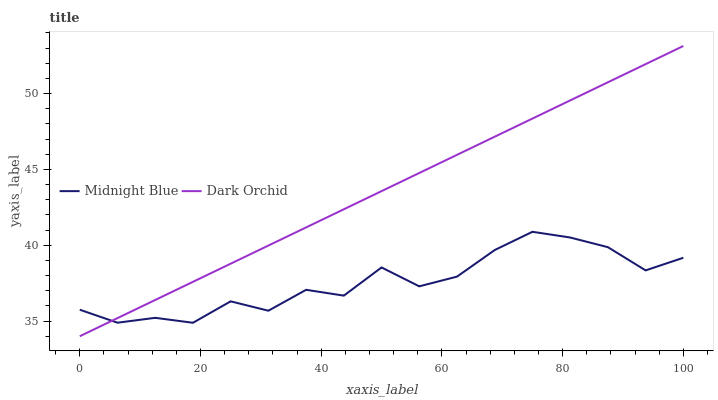Does Midnight Blue have the minimum area under the curve?
Answer yes or no. Yes. Does Dark Orchid have the maximum area under the curve?
Answer yes or no. Yes. Does Dark Orchid have the minimum area under the curve?
Answer yes or no. No. Is Dark Orchid the smoothest?
Answer yes or no. Yes. Is Midnight Blue the roughest?
Answer yes or no. Yes. Is Dark Orchid the roughest?
Answer yes or no. No. Does Dark Orchid have the lowest value?
Answer yes or no. Yes. Does Dark Orchid have the highest value?
Answer yes or no. Yes. Does Midnight Blue intersect Dark Orchid?
Answer yes or no. Yes. Is Midnight Blue less than Dark Orchid?
Answer yes or no. No. Is Midnight Blue greater than Dark Orchid?
Answer yes or no. No. 